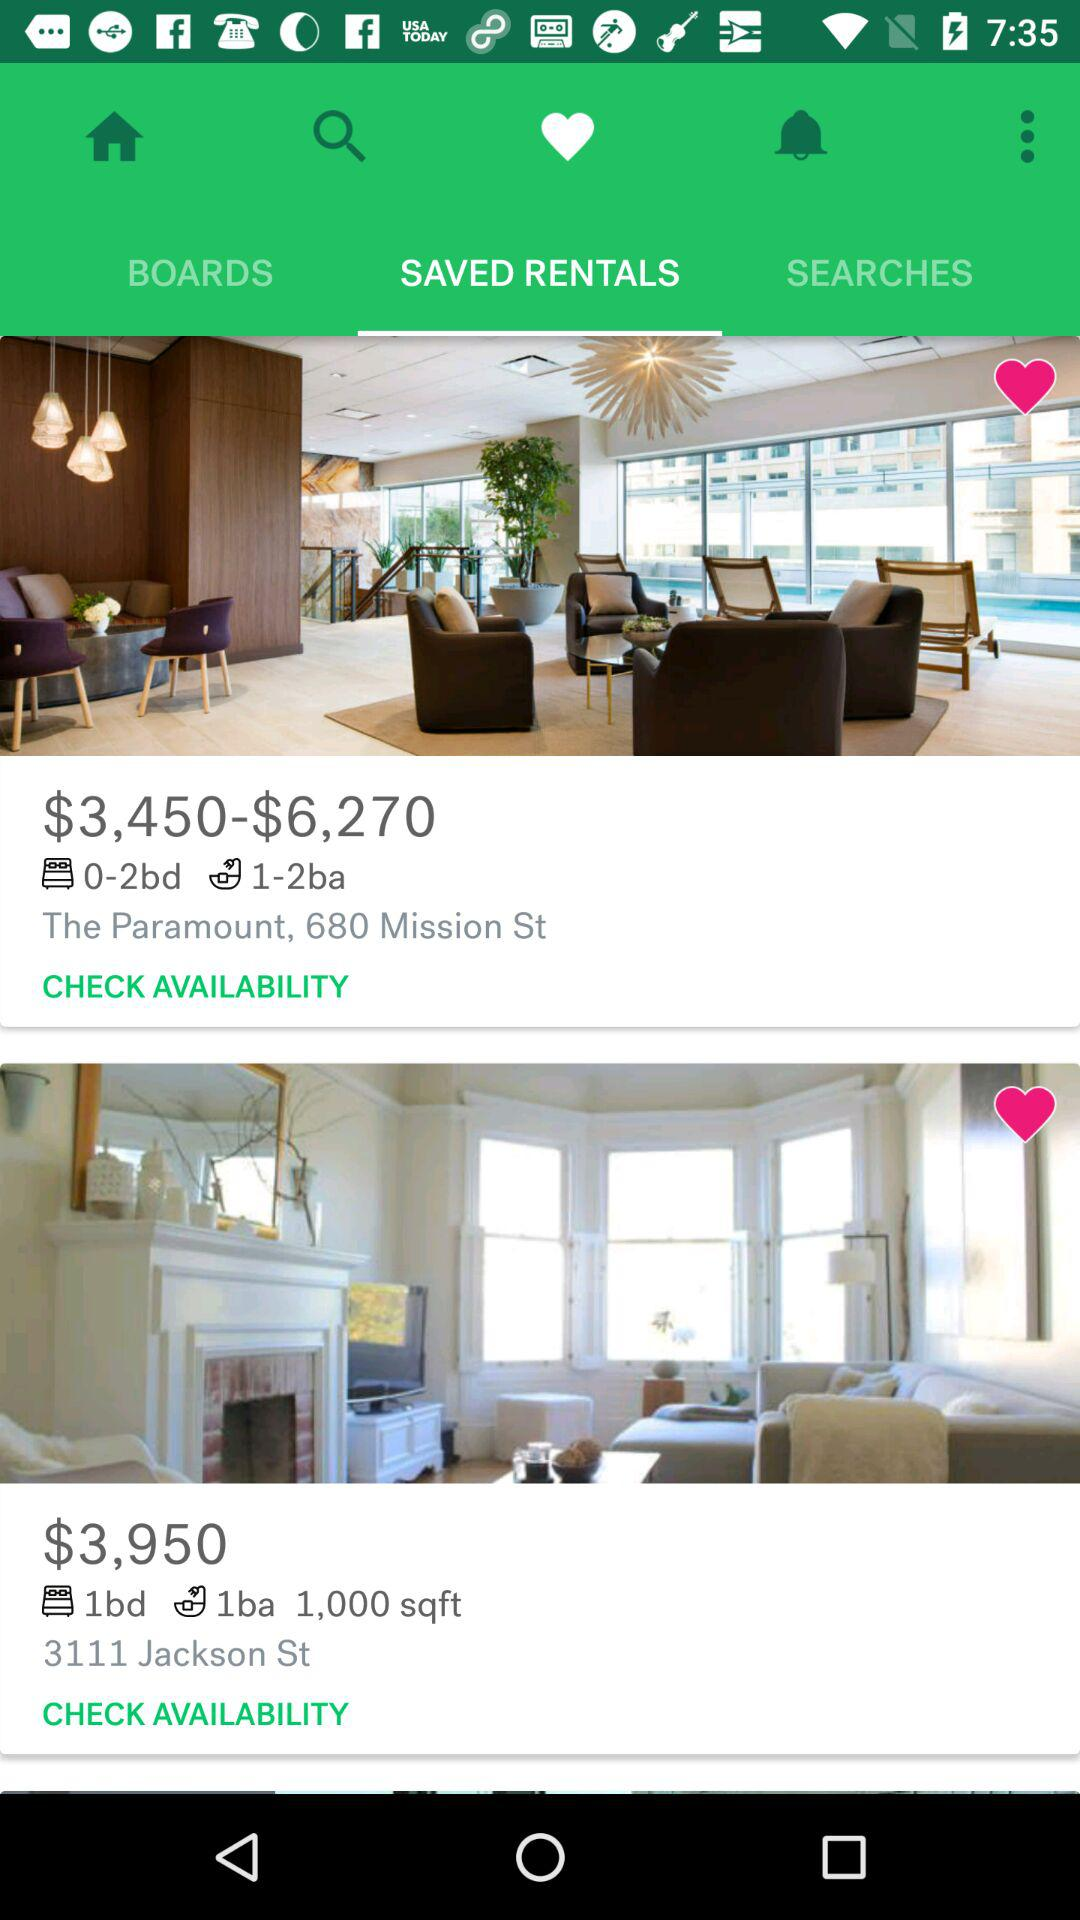What is the price range for the rental room with up to two bedrooms and two bathrooms? The price range for the rental room with up to two bedrooms and two bathrooms is from $3,450 to $6,270. 